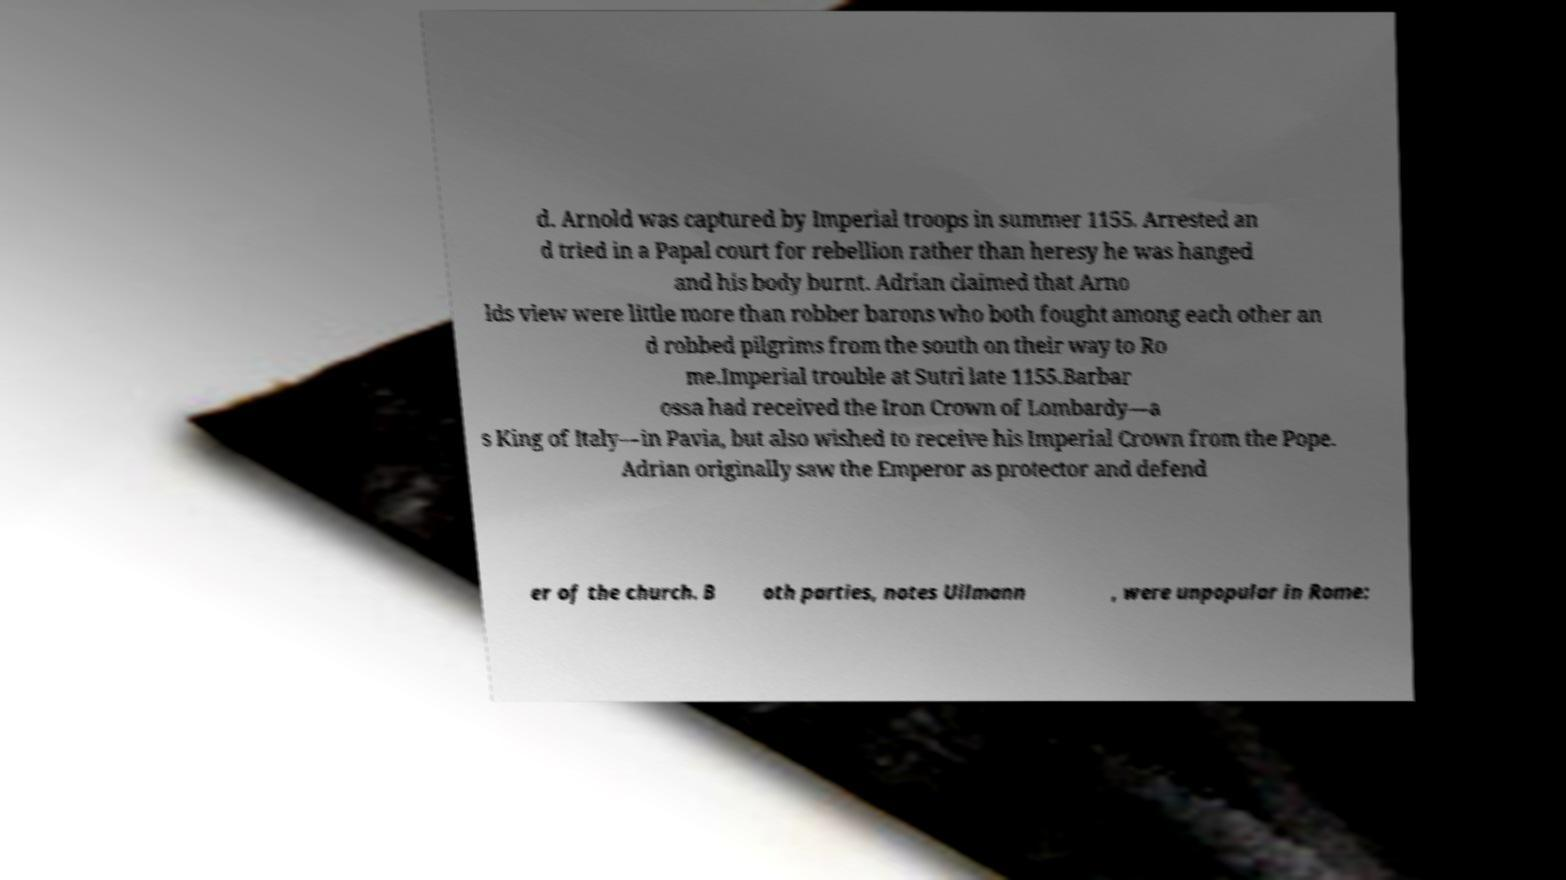What messages or text are displayed in this image? I need them in a readable, typed format. d. Arnold was captured by Imperial troops in summer 1155. Arrested an d tried in a Papal court for rebellion rather than heresy he was hanged and his body burnt. Adrian claimed that Arno lds view were little more than robber barons who both fought among each other an d robbed pilgrims from the south on their way to Ro me.Imperial trouble at Sutri late 1155.Barbar ossa had received the Iron Crown of Lombardy—a s King of Italy—in Pavia, but also wished to receive his Imperial Crown from the Pope. Adrian originally saw the Emperor as protector and defend er of the church. B oth parties, notes Ullmann , were unpopular in Rome: 